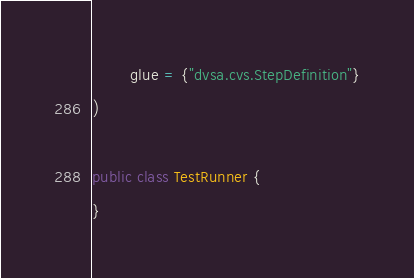Convert code to text. <code><loc_0><loc_0><loc_500><loc_500><_Java_>        glue = {"dvsa.cvs.StepDefinition"}
)

public class TestRunner {
}
</code> 